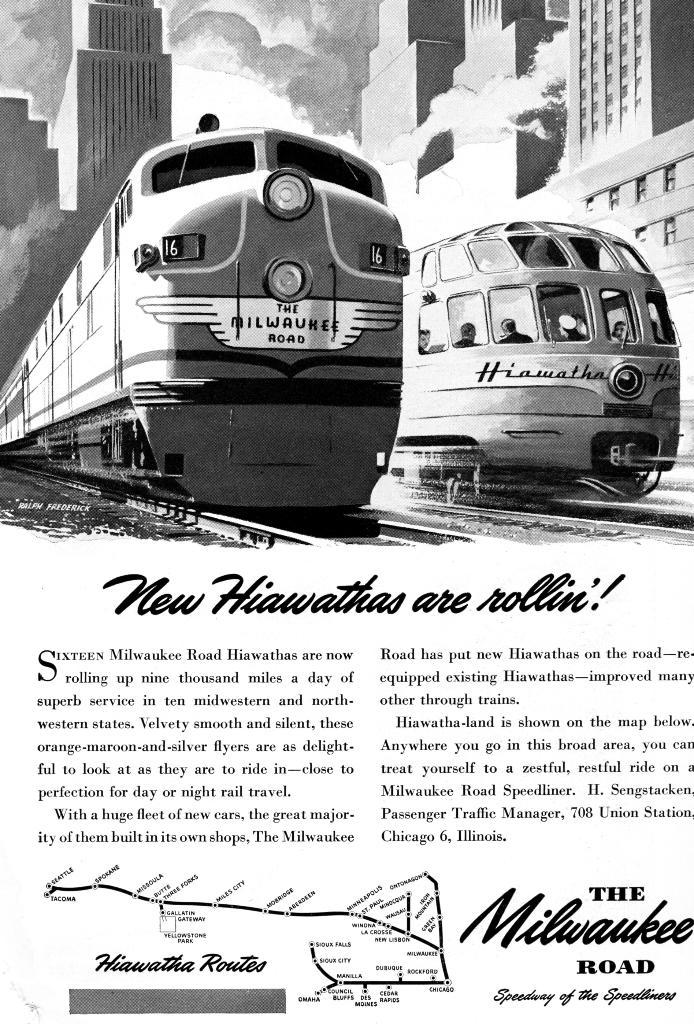What is the main subject of the image? The main subject of the image is a paper. What can be seen on the paper? The paper contains drawings or images of smoke, buildings, railway tracks, and trains. Is there any text or writing on the paper? Yes, there is text or writing on the paper. What type of rhythm can be heard in the background of the image? There is no sound or rhythm present in the image, as it is a static image of a paper with drawings and text. 